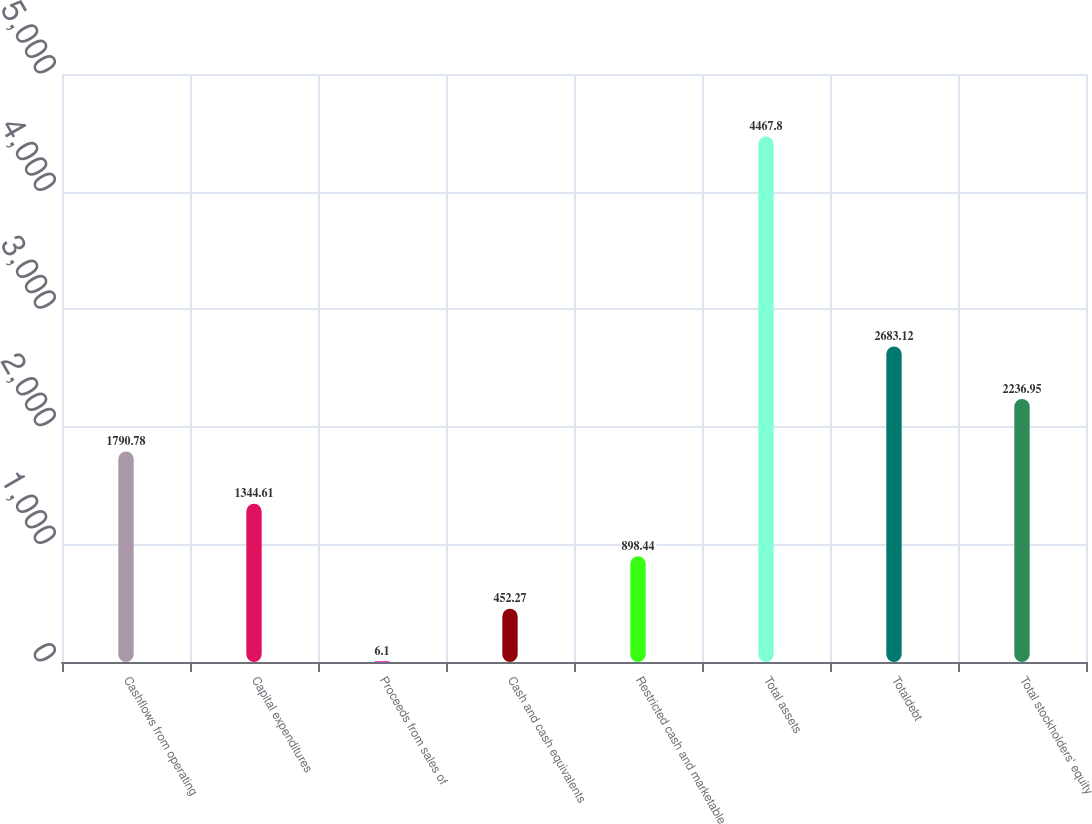Convert chart. <chart><loc_0><loc_0><loc_500><loc_500><bar_chart><fcel>Cashflows from operating<fcel>Capital expenditures<fcel>Proceeds from sales of<fcel>Cash and cash equivalents<fcel>Restricted cash and marketable<fcel>Total assets<fcel>Totaldebt<fcel>Total stockholders' equity<nl><fcel>1790.78<fcel>1344.61<fcel>6.1<fcel>452.27<fcel>898.44<fcel>4467.8<fcel>2683.12<fcel>2236.95<nl></chart> 